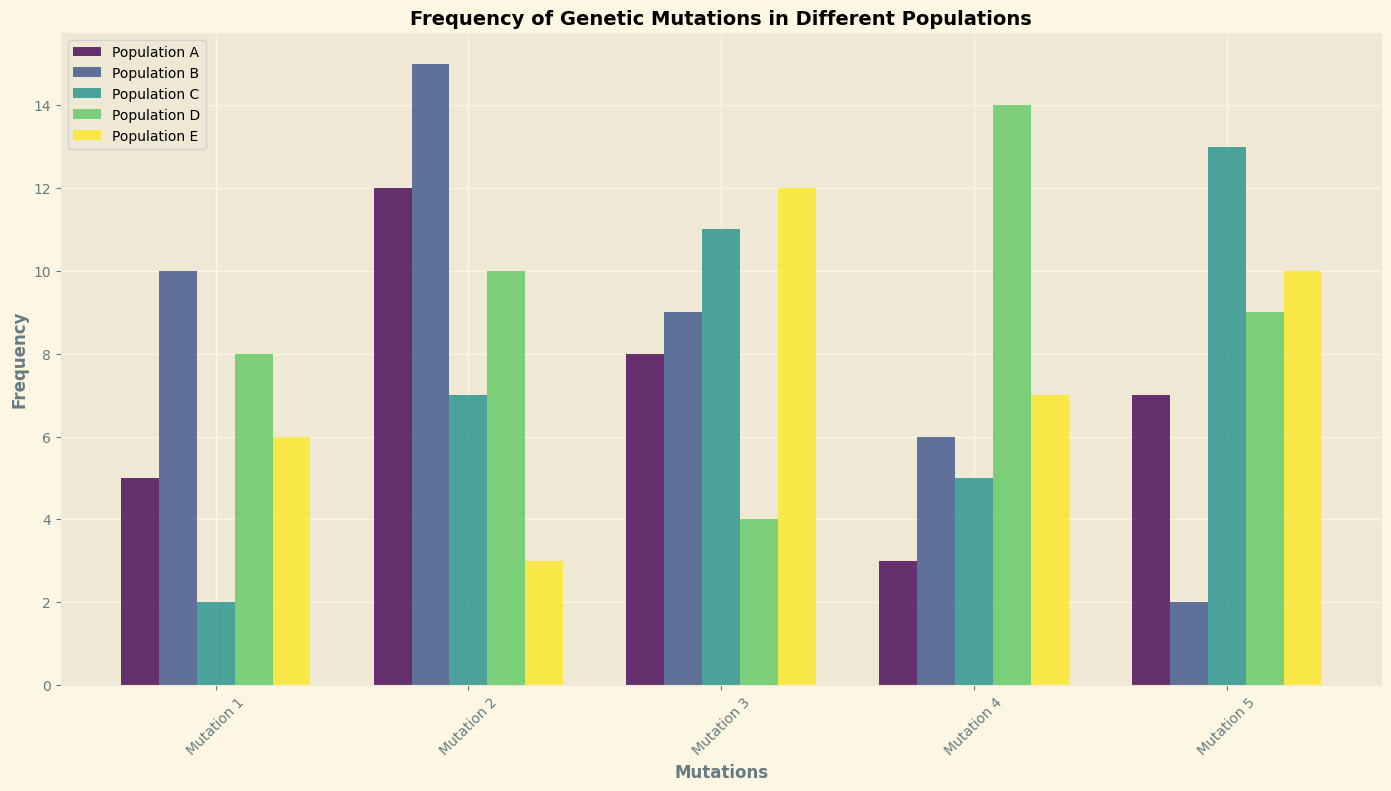What is the frequency of Mutation 1 in Population A? By looking at the height of the bar corresponding to Mutation 1 under the Population A section, you can see the frequency value.
Answer: 5 Which mutation has the highest frequency in Population C? By comparing the heights of all bars within the Population C section, Mutation 5 has the highest bar.
Answer: Mutation 5 What is the difference in frequency of Mutation 2 between Population B and Population D? Find the heights of the bars corresponding to Mutation 2 for both Populations B and D, then subtract the smaller value from the larger value (15 - 10 = 5).
Answer: 5 What is the average frequency of mutations in Population E? Sum all the frequency values for Population E (6 + 3 + 12 + 7 + 10 = 38) and divide by the number of mutations (38/5 = 7.6).
Answer: 7.6 Which population has the lowest frequency for Mutation 4? By comparing the heights of the bars for Mutation 4 across all populations, Population A has the shortest bar.
Answer: Population A How many mutations in Population B have a frequency greater than 5? Count the bars whose heights are greater than the value of 5 in the Population B section. (Mutation 1, Mutation 2, Mutation 3, and Mutation 4, so 4 mutations).
Answer: 4 Which population has the most consistent frequency of mutations (i.e., least variation in heights)? Visually compare the bars within each population section for uniformity in their heights. Population E appears to have the most consistent bar heights.
Answer: Population E What is the total frequency for Mutation 3 across all populations? Add the heights of the bars for Mutation 3 across all populations (8 + 9 + 11 + 4 + 12 = 44).
Answer: 44 Which mutation shows the greatest variation in frequency across different populations? Compare the range (highest frequency minus lowest frequency) for each mutation across populations. Mutation 4 ranges from 3 to 14 (variation of 11), which is the greatest.
Answer: Mutation 4 